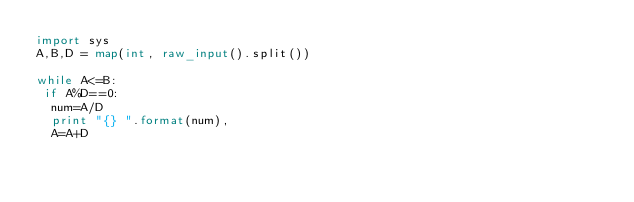<code> <loc_0><loc_0><loc_500><loc_500><_Python_>import sys
A,B,D = map(int, raw_input().split())

while A<=B:
 if A%D==0:
  num=A/D
  print "{} ".format(num),
  A=A+D</code> 